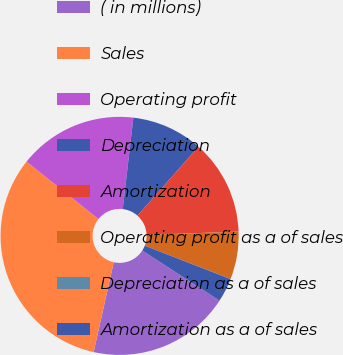Convert chart to OTSL. <chart><loc_0><loc_0><loc_500><loc_500><pie_chart><fcel>( in millions)<fcel>Sales<fcel>Operating profit<fcel>Depreciation<fcel>Amortization<fcel>Operating profit as a of sales<fcel>Depreciation as a of sales<fcel>Amortization as a of sales<nl><fcel>19.35%<fcel>32.23%<fcel>16.12%<fcel>9.68%<fcel>12.9%<fcel>6.46%<fcel>0.02%<fcel>3.24%<nl></chart> 